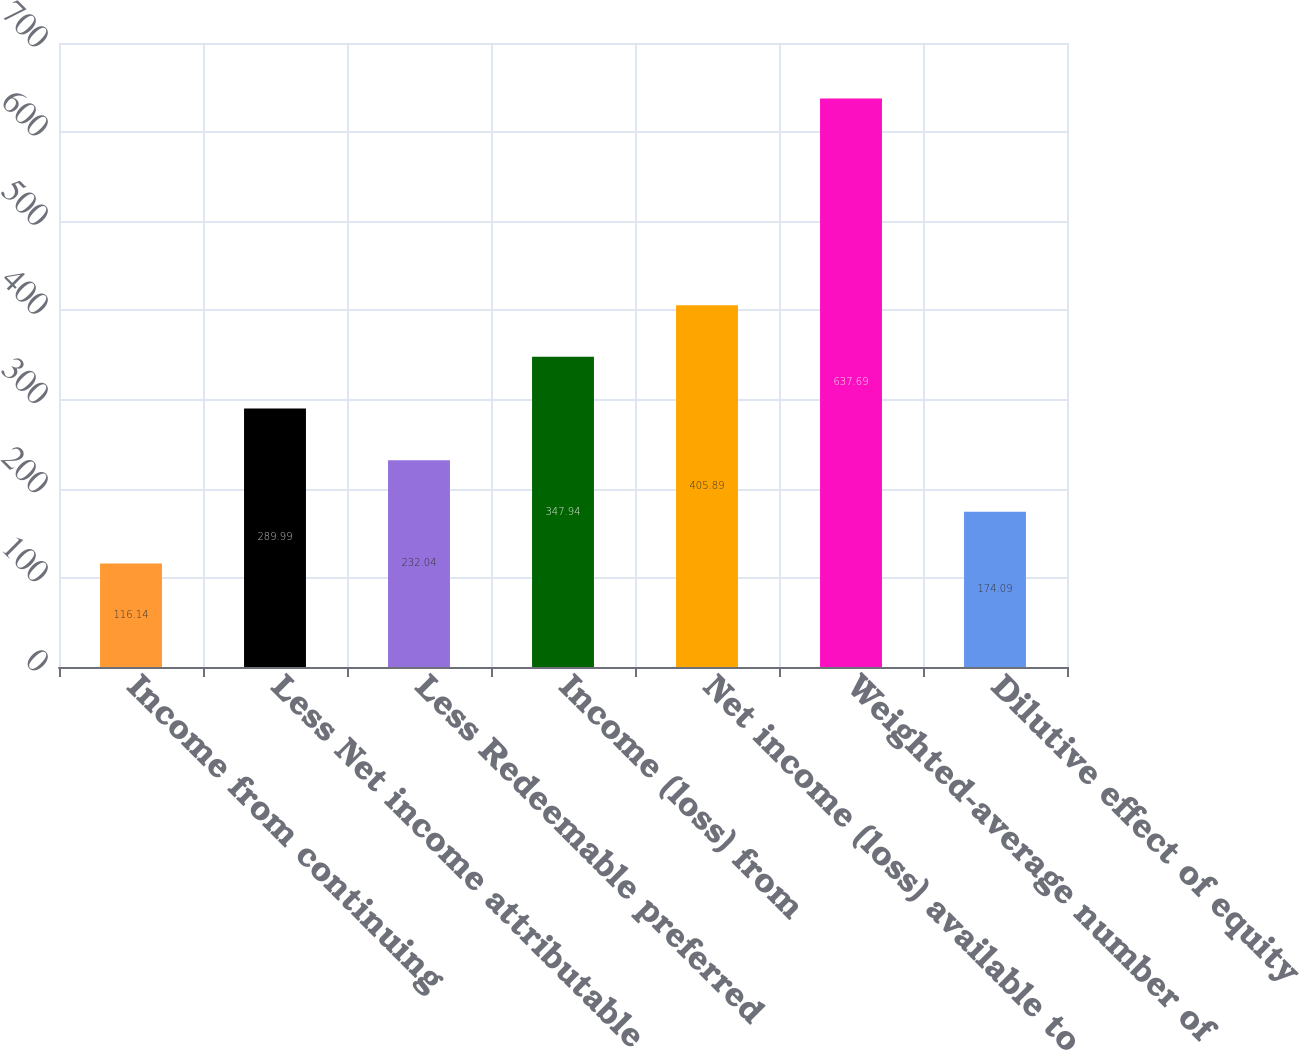<chart> <loc_0><loc_0><loc_500><loc_500><bar_chart><fcel>Income from continuing<fcel>Less Net income attributable<fcel>Less Redeemable preferred<fcel>Income (loss) from<fcel>Net income (loss) available to<fcel>Weighted-average number of<fcel>Dilutive effect of equity<nl><fcel>116.14<fcel>289.99<fcel>232.04<fcel>347.94<fcel>405.89<fcel>637.69<fcel>174.09<nl></chart> 